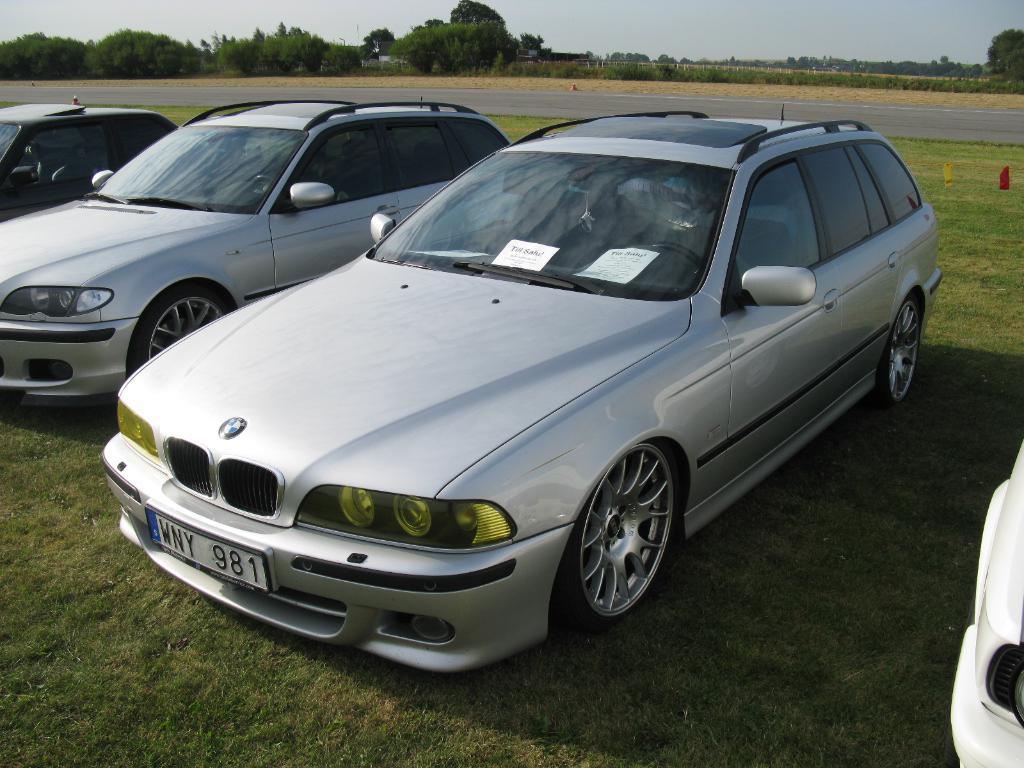Please provide a concise description of this image. In this image we can see few vehicles and behind there is a road and we can see some trees and grass on the ground and in the background, we can see the sky. 